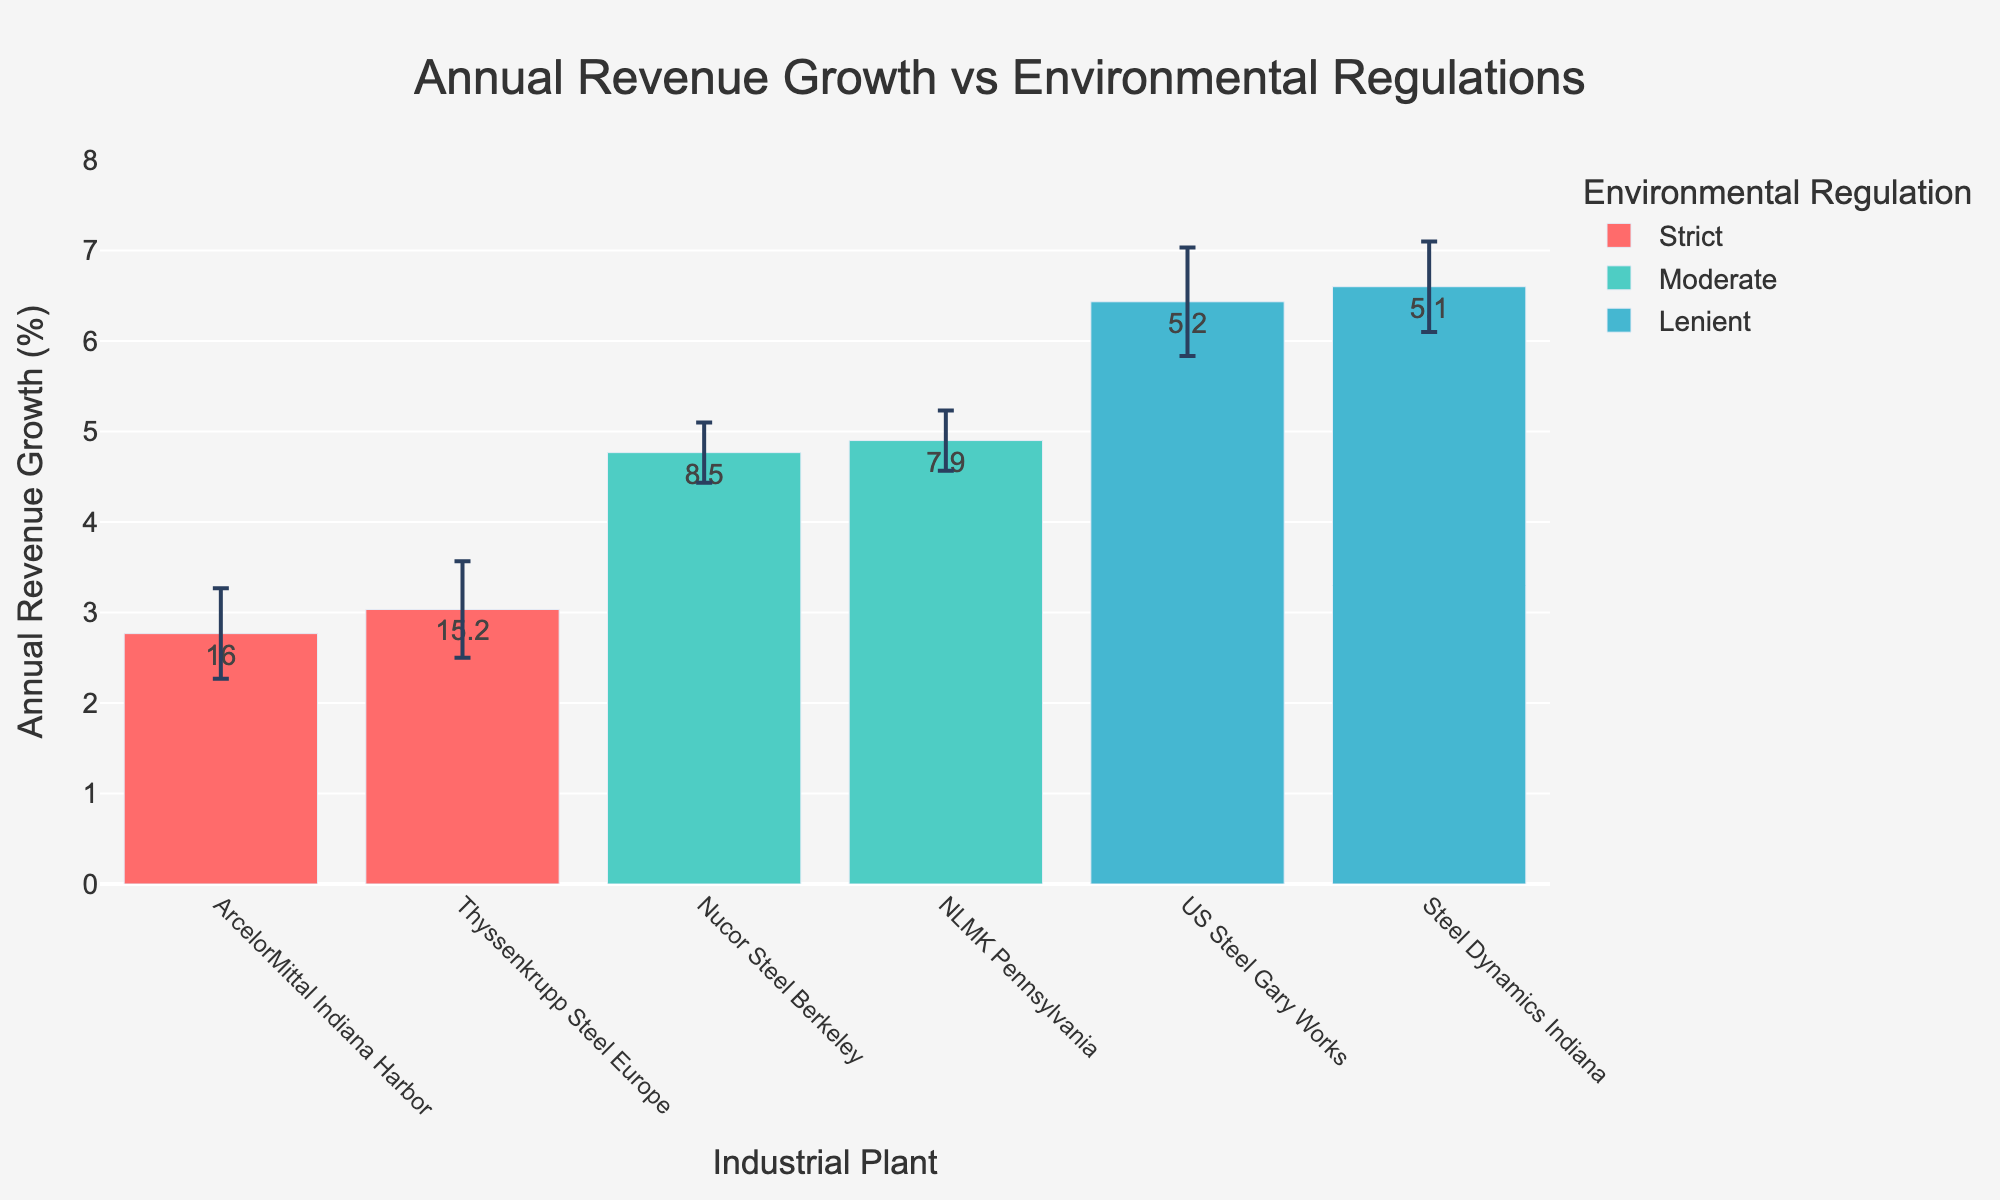What is the title of the figure? The title is usually placed at the top of the figure and is centered. By reading it, we find that it helps to understand the overall context of the plot.
Answer: Annual Revenue Growth vs Environmental Regulations Which environmental regulation category has the highest average revenue growth? To determine this, we need to compare the average annual revenue growth percentages among the 'Strict,' 'Moderate,' and 'Lenient' categories as depicted by the bar heights and error bars.
Answer: Lenient What is the average compliance cost for plants with moderate environmental regulations? Looking at the bars labeled with "Moderate," we need to read the text above these bars to find the average compliance cost for each plant and calculate the overall average of these values.
Answer: $8.3M Which industrial plant has the highest annual revenue growth, and what is that growth percentage? By examining the bar heights, locate the tallest bar and read its corresponding plant name and growth percentage from the hover template or bar text.
Answer: Steel Dynamics Indiana, 6.9% How does Thyssenkrupp Steel Europe's revenue growth compare to ArcelorMittal Indiana Harbor's? Compare the heights and error bars of the bars associated with both plants, reading off their average revenue growth percentages.
Answer: Thyssenkrupp Steel Europe has slightly higher revenue growth than ArcelorMittal Indiana Harbor What is the annual revenue growth of Nucor Steel Berkeley in 2020, and how does its compliance cost compare to the NLMK Pennsylvania? First, identify the bar representing Nucor Steel Berkeley’s growth in 2020 and its growth percentage. Then, compare the text labels above the bars for compliance costs of both Nucor Steel Berkeley and NLMK Pennsylvania.
Answer: 5.0%, Higher What can you infer from the error bars of different plants in terms of the reliability of the annual revenue growth estimates? Evaluate the length of the error bars. Shorter error bars indicate more reliable estimates while longer error bars suggest more variability and less confidence in the growth percentage.
Answer: Generally, plants with 'Moderate' regulations have shorter error bars, indicating more reliable estimates Which plant has the smallest error margin in annual revenue growth, and what is the margin? Find the bar with the shortest error bar by comparing the length of the error bars representing standard errors.
Answer: Nucor Steel Berkeley, 0.3% What trend can be observed in compliance costs and revenue growth across different environmental regulations? Observe the relationship between the compliance cost (as indicated by the text on the bars) and revenue growth percentage across different regulation categories. Note any consistent patterns.
Answer: Higher compliance costs (Strict) tend to be associated with lower revenue growth How does the compliance cost of US Steel Gary Works compare to Steel Dynamics Indiana, and how does their revenue growth differ? Compare the text above their bars for compliance costs and observe their respective bar heights for revenue growth percentages.
Answer: US Steel Gary Works has higher compliance costs but slightly lower revenue growth compared to Steel Dynamics Indiana 